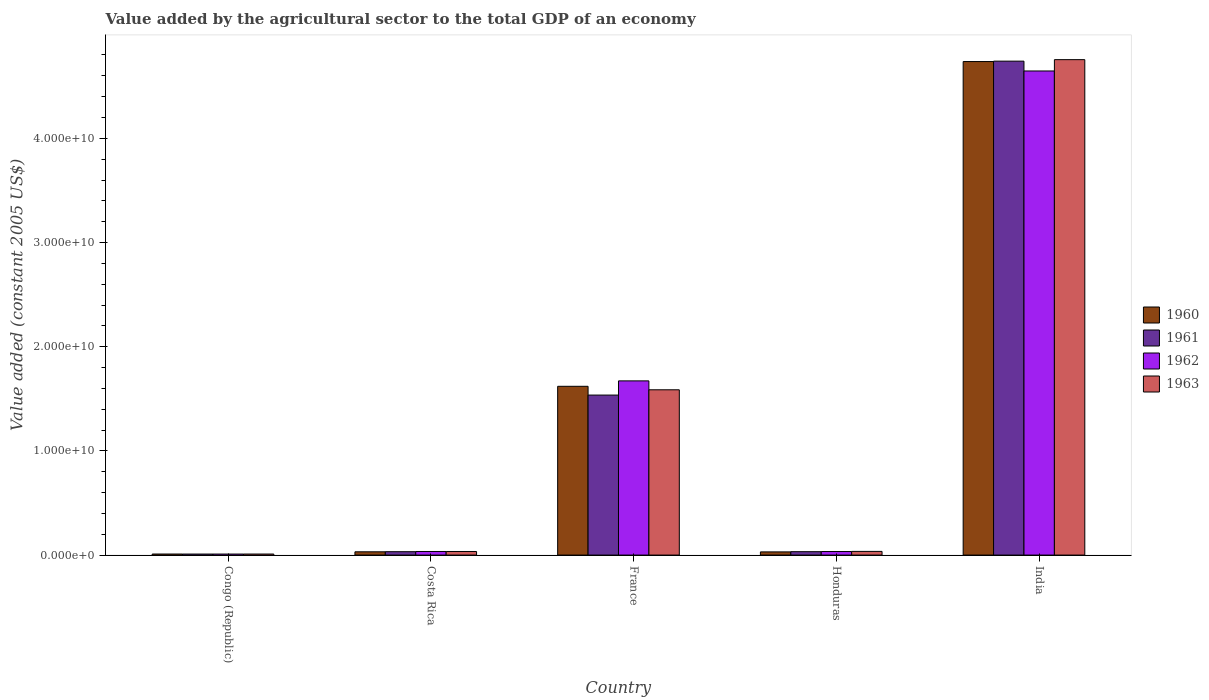How many groups of bars are there?
Provide a short and direct response. 5. What is the label of the 1st group of bars from the left?
Your answer should be very brief. Congo (Republic). In how many cases, is the number of bars for a given country not equal to the number of legend labels?
Your response must be concise. 0. What is the value added by the agricultural sector in 1961 in India?
Make the answer very short. 4.74e+1. Across all countries, what is the maximum value added by the agricultural sector in 1961?
Make the answer very short. 4.74e+1. Across all countries, what is the minimum value added by the agricultural sector in 1961?
Ensure brevity in your answer.  9.74e+07. In which country was the value added by the agricultural sector in 1961 maximum?
Provide a short and direct response. India. In which country was the value added by the agricultural sector in 1961 minimum?
Your answer should be compact. Congo (Republic). What is the total value added by the agricultural sector in 1962 in the graph?
Your response must be concise. 6.40e+1. What is the difference between the value added by the agricultural sector in 1963 in Costa Rica and that in France?
Offer a terse response. -1.55e+1. What is the difference between the value added by the agricultural sector in 1962 in Honduras and the value added by the agricultural sector in 1961 in France?
Ensure brevity in your answer.  -1.50e+1. What is the average value added by the agricultural sector in 1963 per country?
Provide a short and direct response. 1.28e+1. What is the difference between the value added by the agricultural sector of/in 1961 and value added by the agricultural sector of/in 1963 in Costa Rica?
Keep it short and to the point. -1.89e+07. What is the ratio of the value added by the agricultural sector in 1962 in Congo (Republic) to that in India?
Keep it short and to the point. 0. Is the difference between the value added by the agricultural sector in 1961 in Costa Rica and India greater than the difference between the value added by the agricultural sector in 1963 in Costa Rica and India?
Ensure brevity in your answer.  Yes. What is the difference between the highest and the second highest value added by the agricultural sector in 1960?
Your answer should be compact. 3.12e+1. What is the difference between the highest and the lowest value added by the agricultural sector in 1961?
Make the answer very short. 4.73e+1. What does the 1st bar from the right in Honduras represents?
Provide a short and direct response. 1963. Is it the case that in every country, the sum of the value added by the agricultural sector in 1960 and value added by the agricultural sector in 1963 is greater than the value added by the agricultural sector in 1962?
Provide a succinct answer. Yes. Are all the bars in the graph horizontal?
Your answer should be compact. No. What is the difference between two consecutive major ticks on the Y-axis?
Offer a very short reply. 1.00e+1. Where does the legend appear in the graph?
Provide a succinct answer. Center right. How are the legend labels stacked?
Your answer should be compact. Vertical. What is the title of the graph?
Your response must be concise. Value added by the agricultural sector to the total GDP of an economy. What is the label or title of the X-axis?
Provide a succinct answer. Country. What is the label or title of the Y-axis?
Keep it short and to the point. Value added (constant 2005 US$). What is the Value added (constant 2005 US$) in 1960 in Congo (Republic)?
Offer a very short reply. 1.01e+08. What is the Value added (constant 2005 US$) in 1961 in Congo (Republic)?
Provide a short and direct response. 9.74e+07. What is the Value added (constant 2005 US$) of 1962 in Congo (Republic)?
Make the answer very short. 9.79e+07. What is the Value added (constant 2005 US$) in 1963 in Congo (Republic)?
Provide a succinct answer. 9.86e+07. What is the Value added (constant 2005 US$) of 1960 in Costa Rica?
Offer a terse response. 3.13e+08. What is the Value added (constant 2005 US$) in 1961 in Costa Rica?
Ensure brevity in your answer.  3.24e+08. What is the Value added (constant 2005 US$) in 1962 in Costa Rica?
Your answer should be very brief. 3.44e+08. What is the Value added (constant 2005 US$) in 1963 in Costa Rica?
Make the answer very short. 3.43e+08. What is the Value added (constant 2005 US$) of 1960 in France?
Keep it short and to the point. 1.62e+1. What is the Value added (constant 2005 US$) in 1961 in France?
Ensure brevity in your answer.  1.54e+1. What is the Value added (constant 2005 US$) of 1962 in France?
Your answer should be very brief. 1.67e+1. What is the Value added (constant 2005 US$) in 1963 in France?
Provide a succinct answer. 1.59e+1. What is the Value added (constant 2005 US$) of 1960 in Honduras?
Offer a very short reply. 3.05e+08. What is the Value added (constant 2005 US$) of 1961 in Honduras?
Offer a very short reply. 3.25e+08. What is the Value added (constant 2005 US$) in 1962 in Honduras?
Your response must be concise. 3.41e+08. What is the Value added (constant 2005 US$) in 1963 in Honduras?
Provide a short and direct response. 3.53e+08. What is the Value added (constant 2005 US$) of 1960 in India?
Your answer should be very brief. 4.74e+1. What is the Value added (constant 2005 US$) of 1961 in India?
Provide a succinct answer. 4.74e+1. What is the Value added (constant 2005 US$) in 1962 in India?
Your response must be concise. 4.65e+1. What is the Value added (constant 2005 US$) in 1963 in India?
Offer a very short reply. 4.76e+1. Across all countries, what is the maximum Value added (constant 2005 US$) in 1960?
Your answer should be compact. 4.74e+1. Across all countries, what is the maximum Value added (constant 2005 US$) of 1961?
Give a very brief answer. 4.74e+1. Across all countries, what is the maximum Value added (constant 2005 US$) in 1962?
Your answer should be compact. 4.65e+1. Across all countries, what is the maximum Value added (constant 2005 US$) of 1963?
Your answer should be very brief. 4.76e+1. Across all countries, what is the minimum Value added (constant 2005 US$) of 1960?
Ensure brevity in your answer.  1.01e+08. Across all countries, what is the minimum Value added (constant 2005 US$) of 1961?
Your response must be concise. 9.74e+07. Across all countries, what is the minimum Value added (constant 2005 US$) in 1962?
Offer a terse response. 9.79e+07. Across all countries, what is the minimum Value added (constant 2005 US$) of 1963?
Your answer should be compact. 9.86e+07. What is the total Value added (constant 2005 US$) in 1960 in the graph?
Your answer should be compact. 6.43e+1. What is the total Value added (constant 2005 US$) of 1961 in the graph?
Your answer should be very brief. 6.35e+1. What is the total Value added (constant 2005 US$) of 1962 in the graph?
Your answer should be very brief. 6.40e+1. What is the total Value added (constant 2005 US$) of 1963 in the graph?
Provide a succinct answer. 6.42e+1. What is the difference between the Value added (constant 2005 US$) in 1960 in Congo (Republic) and that in Costa Rica?
Make the answer very short. -2.12e+08. What is the difference between the Value added (constant 2005 US$) in 1961 in Congo (Republic) and that in Costa Rica?
Keep it short and to the point. -2.27e+08. What is the difference between the Value added (constant 2005 US$) of 1962 in Congo (Republic) and that in Costa Rica?
Provide a succinct answer. -2.46e+08. What is the difference between the Value added (constant 2005 US$) of 1963 in Congo (Republic) and that in Costa Rica?
Provide a short and direct response. -2.45e+08. What is the difference between the Value added (constant 2005 US$) in 1960 in Congo (Republic) and that in France?
Make the answer very short. -1.61e+1. What is the difference between the Value added (constant 2005 US$) of 1961 in Congo (Republic) and that in France?
Your response must be concise. -1.53e+1. What is the difference between the Value added (constant 2005 US$) of 1962 in Congo (Republic) and that in France?
Make the answer very short. -1.66e+1. What is the difference between the Value added (constant 2005 US$) of 1963 in Congo (Republic) and that in France?
Provide a succinct answer. -1.58e+1. What is the difference between the Value added (constant 2005 US$) of 1960 in Congo (Republic) and that in Honduras?
Your response must be concise. -2.04e+08. What is the difference between the Value added (constant 2005 US$) in 1961 in Congo (Republic) and that in Honduras?
Keep it short and to the point. -2.28e+08. What is the difference between the Value added (constant 2005 US$) of 1962 in Congo (Republic) and that in Honduras?
Your answer should be very brief. -2.43e+08. What is the difference between the Value added (constant 2005 US$) of 1963 in Congo (Republic) and that in Honduras?
Offer a terse response. -2.55e+08. What is the difference between the Value added (constant 2005 US$) in 1960 in Congo (Republic) and that in India?
Offer a terse response. -4.73e+1. What is the difference between the Value added (constant 2005 US$) in 1961 in Congo (Republic) and that in India?
Provide a short and direct response. -4.73e+1. What is the difference between the Value added (constant 2005 US$) in 1962 in Congo (Republic) and that in India?
Your answer should be very brief. -4.64e+1. What is the difference between the Value added (constant 2005 US$) in 1963 in Congo (Republic) and that in India?
Offer a very short reply. -4.75e+1. What is the difference between the Value added (constant 2005 US$) of 1960 in Costa Rica and that in France?
Make the answer very short. -1.59e+1. What is the difference between the Value added (constant 2005 US$) in 1961 in Costa Rica and that in France?
Provide a short and direct response. -1.50e+1. What is the difference between the Value added (constant 2005 US$) in 1962 in Costa Rica and that in France?
Your answer should be very brief. -1.64e+1. What is the difference between the Value added (constant 2005 US$) of 1963 in Costa Rica and that in France?
Keep it short and to the point. -1.55e+1. What is the difference between the Value added (constant 2005 US$) in 1960 in Costa Rica and that in Honduras?
Your response must be concise. 7.61e+06. What is the difference between the Value added (constant 2005 US$) in 1961 in Costa Rica and that in Honduras?
Keep it short and to the point. -8.14e+05. What is the difference between the Value added (constant 2005 US$) of 1962 in Costa Rica and that in Honduras?
Make the answer very short. 3.61e+06. What is the difference between the Value added (constant 2005 US$) in 1963 in Costa Rica and that in Honduras?
Provide a short and direct response. -9.78e+06. What is the difference between the Value added (constant 2005 US$) of 1960 in Costa Rica and that in India?
Keep it short and to the point. -4.71e+1. What is the difference between the Value added (constant 2005 US$) in 1961 in Costa Rica and that in India?
Your answer should be very brief. -4.71e+1. What is the difference between the Value added (constant 2005 US$) in 1962 in Costa Rica and that in India?
Keep it short and to the point. -4.61e+1. What is the difference between the Value added (constant 2005 US$) of 1963 in Costa Rica and that in India?
Your answer should be very brief. -4.72e+1. What is the difference between the Value added (constant 2005 US$) in 1960 in France and that in Honduras?
Your answer should be very brief. 1.59e+1. What is the difference between the Value added (constant 2005 US$) of 1961 in France and that in Honduras?
Your response must be concise. 1.50e+1. What is the difference between the Value added (constant 2005 US$) in 1962 in France and that in Honduras?
Your answer should be very brief. 1.64e+1. What is the difference between the Value added (constant 2005 US$) in 1963 in France and that in Honduras?
Ensure brevity in your answer.  1.55e+1. What is the difference between the Value added (constant 2005 US$) of 1960 in France and that in India?
Give a very brief answer. -3.12e+1. What is the difference between the Value added (constant 2005 US$) in 1961 in France and that in India?
Offer a terse response. -3.21e+1. What is the difference between the Value added (constant 2005 US$) in 1962 in France and that in India?
Your answer should be very brief. -2.97e+1. What is the difference between the Value added (constant 2005 US$) of 1963 in France and that in India?
Give a very brief answer. -3.17e+1. What is the difference between the Value added (constant 2005 US$) of 1960 in Honduras and that in India?
Keep it short and to the point. -4.71e+1. What is the difference between the Value added (constant 2005 US$) in 1961 in Honduras and that in India?
Give a very brief answer. -4.71e+1. What is the difference between the Value added (constant 2005 US$) in 1962 in Honduras and that in India?
Keep it short and to the point. -4.61e+1. What is the difference between the Value added (constant 2005 US$) in 1963 in Honduras and that in India?
Keep it short and to the point. -4.72e+1. What is the difference between the Value added (constant 2005 US$) in 1960 in Congo (Republic) and the Value added (constant 2005 US$) in 1961 in Costa Rica?
Your answer should be very brief. -2.24e+08. What is the difference between the Value added (constant 2005 US$) of 1960 in Congo (Republic) and the Value added (constant 2005 US$) of 1962 in Costa Rica?
Provide a short and direct response. -2.43e+08. What is the difference between the Value added (constant 2005 US$) in 1960 in Congo (Republic) and the Value added (constant 2005 US$) in 1963 in Costa Rica?
Your answer should be compact. -2.42e+08. What is the difference between the Value added (constant 2005 US$) of 1961 in Congo (Republic) and the Value added (constant 2005 US$) of 1962 in Costa Rica?
Provide a succinct answer. -2.47e+08. What is the difference between the Value added (constant 2005 US$) in 1961 in Congo (Republic) and the Value added (constant 2005 US$) in 1963 in Costa Rica?
Offer a terse response. -2.46e+08. What is the difference between the Value added (constant 2005 US$) of 1962 in Congo (Republic) and the Value added (constant 2005 US$) of 1963 in Costa Rica?
Offer a very short reply. -2.45e+08. What is the difference between the Value added (constant 2005 US$) in 1960 in Congo (Republic) and the Value added (constant 2005 US$) in 1961 in France?
Give a very brief answer. -1.53e+1. What is the difference between the Value added (constant 2005 US$) in 1960 in Congo (Republic) and the Value added (constant 2005 US$) in 1962 in France?
Your answer should be very brief. -1.66e+1. What is the difference between the Value added (constant 2005 US$) of 1960 in Congo (Republic) and the Value added (constant 2005 US$) of 1963 in France?
Your response must be concise. -1.58e+1. What is the difference between the Value added (constant 2005 US$) of 1961 in Congo (Republic) and the Value added (constant 2005 US$) of 1962 in France?
Provide a short and direct response. -1.66e+1. What is the difference between the Value added (constant 2005 US$) of 1961 in Congo (Republic) and the Value added (constant 2005 US$) of 1963 in France?
Provide a short and direct response. -1.58e+1. What is the difference between the Value added (constant 2005 US$) in 1962 in Congo (Republic) and the Value added (constant 2005 US$) in 1963 in France?
Offer a terse response. -1.58e+1. What is the difference between the Value added (constant 2005 US$) in 1960 in Congo (Republic) and the Value added (constant 2005 US$) in 1961 in Honduras?
Offer a terse response. -2.24e+08. What is the difference between the Value added (constant 2005 US$) in 1960 in Congo (Republic) and the Value added (constant 2005 US$) in 1962 in Honduras?
Provide a succinct answer. -2.40e+08. What is the difference between the Value added (constant 2005 US$) in 1960 in Congo (Republic) and the Value added (constant 2005 US$) in 1963 in Honduras?
Offer a terse response. -2.52e+08. What is the difference between the Value added (constant 2005 US$) in 1961 in Congo (Republic) and the Value added (constant 2005 US$) in 1962 in Honduras?
Provide a succinct answer. -2.43e+08. What is the difference between the Value added (constant 2005 US$) of 1961 in Congo (Republic) and the Value added (constant 2005 US$) of 1963 in Honduras?
Provide a succinct answer. -2.56e+08. What is the difference between the Value added (constant 2005 US$) of 1962 in Congo (Republic) and the Value added (constant 2005 US$) of 1963 in Honduras?
Provide a short and direct response. -2.55e+08. What is the difference between the Value added (constant 2005 US$) of 1960 in Congo (Republic) and the Value added (constant 2005 US$) of 1961 in India?
Give a very brief answer. -4.73e+1. What is the difference between the Value added (constant 2005 US$) of 1960 in Congo (Republic) and the Value added (constant 2005 US$) of 1962 in India?
Your answer should be very brief. -4.64e+1. What is the difference between the Value added (constant 2005 US$) in 1960 in Congo (Republic) and the Value added (constant 2005 US$) in 1963 in India?
Offer a very short reply. -4.75e+1. What is the difference between the Value added (constant 2005 US$) in 1961 in Congo (Republic) and the Value added (constant 2005 US$) in 1962 in India?
Offer a terse response. -4.64e+1. What is the difference between the Value added (constant 2005 US$) of 1961 in Congo (Republic) and the Value added (constant 2005 US$) of 1963 in India?
Offer a very short reply. -4.75e+1. What is the difference between the Value added (constant 2005 US$) in 1962 in Congo (Republic) and the Value added (constant 2005 US$) in 1963 in India?
Offer a very short reply. -4.75e+1. What is the difference between the Value added (constant 2005 US$) of 1960 in Costa Rica and the Value added (constant 2005 US$) of 1961 in France?
Give a very brief answer. -1.50e+1. What is the difference between the Value added (constant 2005 US$) of 1960 in Costa Rica and the Value added (constant 2005 US$) of 1962 in France?
Give a very brief answer. -1.64e+1. What is the difference between the Value added (constant 2005 US$) of 1960 in Costa Rica and the Value added (constant 2005 US$) of 1963 in France?
Ensure brevity in your answer.  -1.56e+1. What is the difference between the Value added (constant 2005 US$) of 1961 in Costa Rica and the Value added (constant 2005 US$) of 1962 in France?
Provide a short and direct response. -1.64e+1. What is the difference between the Value added (constant 2005 US$) in 1961 in Costa Rica and the Value added (constant 2005 US$) in 1963 in France?
Give a very brief answer. -1.55e+1. What is the difference between the Value added (constant 2005 US$) of 1962 in Costa Rica and the Value added (constant 2005 US$) of 1963 in France?
Make the answer very short. -1.55e+1. What is the difference between the Value added (constant 2005 US$) in 1960 in Costa Rica and the Value added (constant 2005 US$) in 1961 in Honduras?
Your response must be concise. -1.23e+07. What is the difference between the Value added (constant 2005 US$) in 1960 in Costa Rica and the Value added (constant 2005 US$) in 1962 in Honduras?
Your answer should be very brief. -2.78e+07. What is the difference between the Value added (constant 2005 US$) of 1960 in Costa Rica and the Value added (constant 2005 US$) of 1963 in Honduras?
Provide a succinct answer. -4.02e+07. What is the difference between the Value added (constant 2005 US$) in 1961 in Costa Rica and the Value added (constant 2005 US$) in 1962 in Honduras?
Your answer should be compact. -1.63e+07. What is the difference between the Value added (constant 2005 US$) of 1961 in Costa Rica and the Value added (constant 2005 US$) of 1963 in Honduras?
Offer a very short reply. -2.87e+07. What is the difference between the Value added (constant 2005 US$) in 1962 in Costa Rica and the Value added (constant 2005 US$) in 1963 in Honduras?
Ensure brevity in your answer.  -8.78e+06. What is the difference between the Value added (constant 2005 US$) in 1960 in Costa Rica and the Value added (constant 2005 US$) in 1961 in India?
Your answer should be very brief. -4.71e+1. What is the difference between the Value added (constant 2005 US$) in 1960 in Costa Rica and the Value added (constant 2005 US$) in 1962 in India?
Your response must be concise. -4.62e+1. What is the difference between the Value added (constant 2005 US$) in 1960 in Costa Rica and the Value added (constant 2005 US$) in 1963 in India?
Give a very brief answer. -4.72e+1. What is the difference between the Value added (constant 2005 US$) in 1961 in Costa Rica and the Value added (constant 2005 US$) in 1962 in India?
Your response must be concise. -4.61e+1. What is the difference between the Value added (constant 2005 US$) in 1961 in Costa Rica and the Value added (constant 2005 US$) in 1963 in India?
Your response must be concise. -4.72e+1. What is the difference between the Value added (constant 2005 US$) of 1962 in Costa Rica and the Value added (constant 2005 US$) of 1963 in India?
Your answer should be compact. -4.72e+1. What is the difference between the Value added (constant 2005 US$) of 1960 in France and the Value added (constant 2005 US$) of 1961 in Honduras?
Ensure brevity in your answer.  1.59e+1. What is the difference between the Value added (constant 2005 US$) in 1960 in France and the Value added (constant 2005 US$) in 1962 in Honduras?
Your answer should be very brief. 1.59e+1. What is the difference between the Value added (constant 2005 US$) in 1960 in France and the Value added (constant 2005 US$) in 1963 in Honduras?
Your response must be concise. 1.58e+1. What is the difference between the Value added (constant 2005 US$) of 1961 in France and the Value added (constant 2005 US$) of 1962 in Honduras?
Offer a terse response. 1.50e+1. What is the difference between the Value added (constant 2005 US$) of 1961 in France and the Value added (constant 2005 US$) of 1963 in Honduras?
Ensure brevity in your answer.  1.50e+1. What is the difference between the Value added (constant 2005 US$) in 1962 in France and the Value added (constant 2005 US$) in 1963 in Honduras?
Make the answer very short. 1.64e+1. What is the difference between the Value added (constant 2005 US$) of 1960 in France and the Value added (constant 2005 US$) of 1961 in India?
Your answer should be compact. -3.12e+1. What is the difference between the Value added (constant 2005 US$) in 1960 in France and the Value added (constant 2005 US$) in 1962 in India?
Provide a succinct answer. -3.03e+1. What is the difference between the Value added (constant 2005 US$) of 1960 in France and the Value added (constant 2005 US$) of 1963 in India?
Ensure brevity in your answer.  -3.14e+1. What is the difference between the Value added (constant 2005 US$) in 1961 in France and the Value added (constant 2005 US$) in 1962 in India?
Your answer should be compact. -3.11e+1. What is the difference between the Value added (constant 2005 US$) in 1961 in France and the Value added (constant 2005 US$) in 1963 in India?
Provide a short and direct response. -3.22e+1. What is the difference between the Value added (constant 2005 US$) of 1962 in France and the Value added (constant 2005 US$) of 1963 in India?
Provide a succinct answer. -3.08e+1. What is the difference between the Value added (constant 2005 US$) in 1960 in Honduras and the Value added (constant 2005 US$) in 1961 in India?
Offer a terse response. -4.71e+1. What is the difference between the Value added (constant 2005 US$) of 1960 in Honduras and the Value added (constant 2005 US$) of 1962 in India?
Provide a short and direct response. -4.62e+1. What is the difference between the Value added (constant 2005 US$) in 1960 in Honduras and the Value added (constant 2005 US$) in 1963 in India?
Your response must be concise. -4.72e+1. What is the difference between the Value added (constant 2005 US$) of 1961 in Honduras and the Value added (constant 2005 US$) of 1962 in India?
Provide a short and direct response. -4.61e+1. What is the difference between the Value added (constant 2005 US$) of 1961 in Honduras and the Value added (constant 2005 US$) of 1963 in India?
Provide a succinct answer. -4.72e+1. What is the difference between the Value added (constant 2005 US$) of 1962 in Honduras and the Value added (constant 2005 US$) of 1963 in India?
Your response must be concise. -4.72e+1. What is the average Value added (constant 2005 US$) in 1960 per country?
Your answer should be very brief. 1.29e+1. What is the average Value added (constant 2005 US$) of 1961 per country?
Keep it short and to the point. 1.27e+1. What is the average Value added (constant 2005 US$) in 1962 per country?
Provide a succinct answer. 1.28e+1. What is the average Value added (constant 2005 US$) of 1963 per country?
Keep it short and to the point. 1.28e+1. What is the difference between the Value added (constant 2005 US$) in 1960 and Value added (constant 2005 US$) in 1961 in Congo (Republic)?
Ensure brevity in your answer.  3.61e+06. What is the difference between the Value added (constant 2005 US$) in 1960 and Value added (constant 2005 US$) in 1962 in Congo (Republic)?
Keep it short and to the point. 3.02e+06. What is the difference between the Value added (constant 2005 US$) in 1960 and Value added (constant 2005 US$) in 1963 in Congo (Republic)?
Your answer should be very brief. 2.34e+06. What is the difference between the Value added (constant 2005 US$) in 1961 and Value added (constant 2005 US$) in 1962 in Congo (Republic)?
Offer a terse response. -5.86e+05. What is the difference between the Value added (constant 2005 US$) in 1961 and Value added (constant 2005 US$) in 1963 in Congo (Republic)?
Provide a short and direct response. -1.27e+06. What is the difference between the Value added (constant 2005 US$) in 1962 and Value added (constant 2005 US$) in 1963 in Congo (Republic)?
Provide a succinct answer. -6.85e+05. What is the difference between the Value added (constant 2005 US$) of 1960 and Value added (constant 2005 US$) of 1961 in Costa Rica?
Make the answer very short. -1.15e+07. What is the difference between the Value added (constant 2005 US$) in 1960 and Value added (constant 2005 US$) in 1962 in Costa Rica?
Keep it short and to the point. -3.14e+07. What is the difference between the Value added (constant 2005 US$) of 1960 and Value added (constant 2005 US$) of 1963 in Costa Rica?
Provide a succinct answer. -3.04e+07. What is the difference between the Value added (constant 2005 US$) of 1961 and Value added (constant 2005 US$) of 1962 in Costa Rica?
Your answer should be compact. -1.99e+07. What is the difference between the Value added (constant 2005 US$) of 1961 and Value added (constant 2005 US$) of 1963 in Costa Rica?
Provide a short and direct response. -1.89e+07. What is the difference between the Value added (constant 2005 US$) of 1962 and Value added (constant 2005 US$) of 1963 in Costa Rica?
Provide a short and direct response. 1.00e+06. What is the difference between the Value added (constant 2005 US$) in 1960 and Value added (constant 2005 US$) in 1961 in France?
Make the answer very short. 8.42e+08. What is the difference between the Value added (constant 2005 US$) of 1960 and Value added (constant 2005 US$) of 1962 in France?
Give a very brief answer. -5.20e+08. What is the difference between the Value added (constant 2005 US$) of 1960 and Value added (constant 2005 US$) of 1963 in France?
Offer a very short reply. 3.35e+08. What is the difference between the Value added (constant 2005 US$) in 1961 and Value added (constant 2005 US$) in 1962 in France?
Keep it short and to the point. -1.36e+09. What is the difference between the Value added (constant 2005 US$) in 1961 and Value added (constant 2005 US$) in 1963 in France?
Make the answer very short. -5.07e+08. What is the difference between the Value added (constant 2005 US$) of 1962 and Value added (constant 2005 US$) of 1963 in France?
Keep it short and to the point. 8.56e+08. What is the difference between the Value added (constant 2005 US$) of 1960 and Value added (constant 2005 US$) of 1961 in Honduras?
Your response must be concise. -1.99e+07. What is the difference between the Value added (constant 2005 US$) in 1960 and Value added (constant 2005 US$) in 1962 in Honduras?
Your response must be concise. -3.54e+07. What is the difference between the Value added (constant 2005 US$) in 1960 and Value added (constant 2005 US$) in 1963 in Honduras?
Give a very brief answer. -4.78e+07. What is the difference between the Value added (constant 2005 US$) of 1961 and Value added (constant 2005 US$) of 1962 in Honduras?
Provide a succinct answer. -1.55e+07. What is the difference between the Value added (constant 2005 US$) in 1961 and Value added (constant 2005 US$) in 1963 in Honduras?
Make the answer very short. -2.79e+07. What is the difference between the Value added (constant 2005 US$) in 1962 and Value added (constant 2005 US$) in 1963 in Honduras?
Provide a succinct answer. -1.24e+07. What is the difference between the Value added (constant 2005 US$) in 1960 and Value added (constant 2005 US$) in 1961 in India?
Keep it short and to the point. -3.99e+07. What is the difference between the Value added (constant 2005 US$) of 1960 and Value added (constant 2005 US$) of 1962 in India?
Your response must be concise. 9.03e+08. What is the difference between the Value added (constant 2005 US$) of 1960 and Value added (constant 2005 US$) of 1963 in India?
Provide a short and direct response. -1.84e+08. What is the difference between the Value added (constant 2005 US$) of 1961 and Value added (constant 2005 US$) of 1962 in India?
Provide a short and direct response. 9.43e+08. What is the difference between the Value added (constant 2005 US$) in 1961 and Value added (constant 2005 US$) in 1963 in India?
Offer a terse response. -1.44e+08. What is the difference between the Value added (constant 2005 US$) of 1962 and Value added (constant 2005 US$) of 1963 in India?
Make the answer very short. -1.09e+09. What is the ratio of the Value added (constant 2005 US$) in 1960 in Congo (Republic) to that in Costa Rica?
Your answer should be very brief. 0.32. What is the ratio of the Value added (constant 2005 US$) in 1961 in Congo (Republic) to that in Costa Rica?
Make the answer very short. 0.3. What is the ratio of the Value added (constant 2005 US$) of 1962 in Congo (Republic) to that in Costa Rica?
Offer a terse response. 0.28. What is the ratio of the Value added (constant 2005 US$) in 1963 in Congo (Republic) to that in Costa Rica?
Provide a succinct answer. 0.29. What is the ratio of the Value added (constant 2005 US$) of 1960 in Congo (Republic) to that in France?
Make the answer very short. 0.01. What is the ratio of the Value added (constant 2005 US$) in 1961 in Congo (Republic) to that in France?
Offer a terse response. 0.01. What is the ratio of the Value added (constant 2005 US$) in 1962 in Congo (Republic) to that in France?
Your response must be concise. 0.01. What is the ratio of the Value added (constant 2005 US$) in 1963 in Congo (Republic) to that in France?
Provide a short and direct response. 0.01. What is the ratio of the Value added (constant 2005 US$) in 1960 in Congo (Republic) to that in Honduras?
Your answer should be very brief. 0.33. What is the ratio of the Value added (constant 2005 US$) of 1961 in Congo (Republic) to that in Honduras?
Provide a short and direct response. 0.3. What is the ratio of the Value added (constant 2005 US$) of 1962 in Congo (Republic) to that in Honduras?
Offer a terse response. 0.29. What is the ratio of the Value added (constant 2005 US$) of 1963 in Congo (Republic) to that in Honduras?
Offer a terse response. 0.28. What is the ratio of the Value added (constant 2005 US$) of 1960 in Congo (Republic) to that in India?
Give a very brief answer. 0. What is the ratio of the Value added (constant 2005 US$) in 1961 in Congo (Republic) to that in India?
Keep it short and to the point. 0. What is the ratio of the Value added (constant 2005 US$) of 1962 in Congo (Republic) to that in India?
Your answer should be compact. 0. What is the ratio of the Value added (constant 2005 US$) in 1963 in Congo (Republic) to that in India?
Your answer should be very brief. 0. What is the ratio of the Value added (constant 2005 US$) of 1960 in Costa Rica to that in France?
Provide a succinct answer. 0.02. What is the ratio of the Value added (constant 2005 US$) in 1961 in Costa Rica to that in France?
Ensure brevity in your answer.  0.02. What is the ratio of the Value added (constant 2005 US$) of 1962 in Costa Rica to that in France?
Provide a short and direct response. 0.02. What is the ratio of the Value added (constant 2005 US$) of 1963 in Costa Rica to that in France?
Your answer should be compact. 0.02. What is the ratio of the Value added (constant 2005 US$) in 1960 in Costa Rica to that in Honduras?
Ensure brevity in your answer.  1.02. What is the ratio of the Value added (constant 2005 US$) in 1961 in Costa Rica to that in Honduras?
Provide a short and direct response. 1. What is the ratio of the Value added (constant 2005 US$) of 1962 in Costa Rica to that in Honduras?
Offer a very short reply. 1.01. What is the ratio of the Value added (constant 2005 US$) in 1963 in Costa Rica to that in Honduras?
Ensure brevity in your answer.  0.97. What is the ratio of the Value added (constant 2005 US$) in 1960 in Costa Rica to that in India?
Offer a terse response. 0.01. What is the ratio of the Value added (constant 2005 US$) in 1961 in Costa Rica to that in India?
Offer a terse response. 0.01. What is the ratio of the Value added (constant 2005 US$) in 1962 in Costa Rica to that in India?
Provide a short and direct response. 0.01. What is the ratio of the Value added (constant 2005 US$) of 1963 in Costa Rica to that in India?
Provide a short and direct response. 0.01. What is the ratio of the Value added (constant 2005 US$) in 1960 in France to that in Honduras?
Make the answer very short. 53.05. What is the ratio of the Value added (constant 2005 US$) of 1961 in France to that in Honduras?
Your answer should be compact. 47.21. What is the ratio of the Value added (constant 2005 US$) in 1962 in France to that in Honduras?
Make the answer very short. 49.07. What is the ratio of the Value added (constant 2005 US$) in 1963 in France to that in Honduras?
Your response must be concise. 44.92. What is the ratio of the Value added (constant 2005 US$) in 1960 in France to that in India?
Give a very brief answer. 0.34. What is the ratio of the Value added (constant 2005 US$) in 1961 in France to that in India?
Your answer should be compact. 0.32. What is the ratio of the Value added (constant 2005 US$) in 1962 in France to that in India?
Provide a succinct answer. 0.36. What is the ratio of the Value added (constant 2005 US$) in 1963 in France to that in India?
Provide a succinct answer. 0.33. What is the ratio of the Value added (constant 2005 US$) of 1960 in Honduras to that in India?
Provide a short and direct response. 0.01. What is the ratio of the Value added (constant 2005 US$) in 1961 in Honduras to that in India?
Offer a terse response. 0.01. What is the ratio of the Value added (constant 2005 US$) in 1962 in Honduras to that in India?
Give a very brief answer. 0.01. What is the ratio of the Value added (constant 2005 US$) in 1963 in Honduras to that in India?
Make the answer very short. 0.01. What is the difference between the highest and the second highest Value added (constant 2005 US$) of 1960?
Offer a terse response. 3.12e+1. What is the difference between the highest and the second highest Value added (constant 2005 US$) of 1961?
Your answer should be compact. 3.21e+1. What is the difference between the highest and the second highest Value added (constant 2005 US$) in 1962?
Your answer should be compact. 2.97e+1. What is the difference between the highest and the second highest Value added (constant 2005 US$) of 1963?
Give a very brief answer. 3.17e+1. What is the difference between the highest and the lowest Value added (constant 2005 US$) of 1960?
Offer a very short reply. 4.73e+1. What is the difference between the highest and the lowest Value added (constant 2005 US$) in 1961?
Provide a short and direct response. 4.73e+1. What is the difference between the highest and the lowest Value added (constant 2005 US$) of 1962?
Your response must be concise. 4.64e+1. What is the difference between the highest and the lowest Value added (constant 2005 US$) of 1963?
Your answer should be very brief. 4.75e+1. 